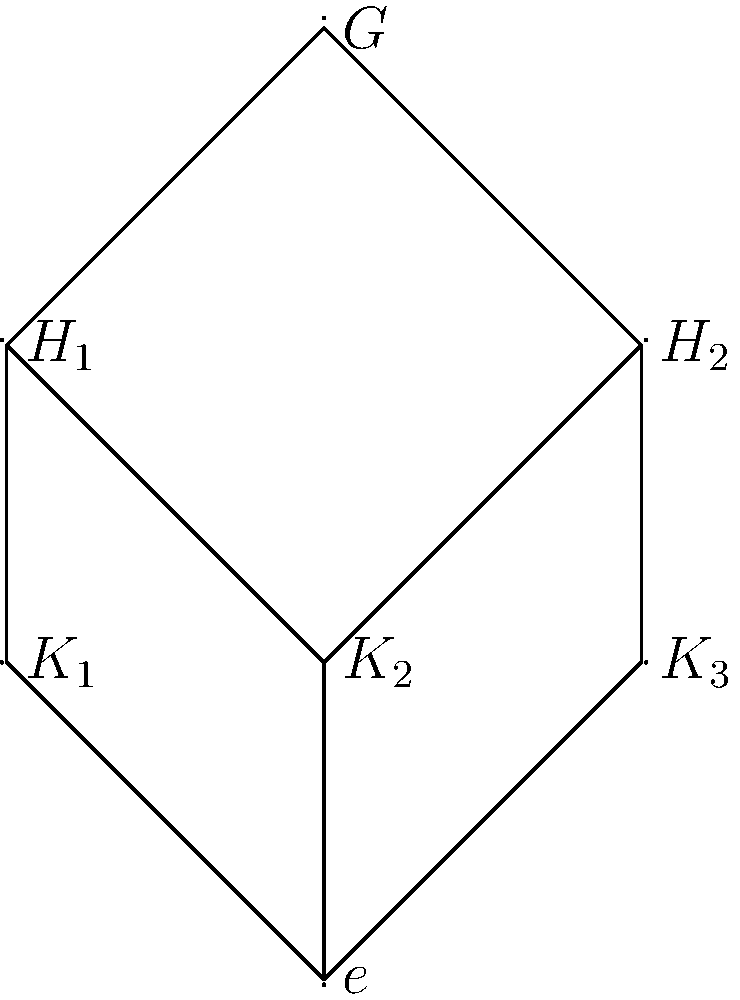Given the subgroup lattice of a group $G$ shown above, which of the following statements is true about the relationship between $H_1$ and $H_2$? Assume you're designing a machine learning algorithm to analyze group structures for efficient transcription of mathematical notations.

a) $H_1 \subset H_2$
b) $H_2 \subset H_1$
c) $H_1 = H_2$
d) $H_1$ and $H_2$ are not directly comparable To answer this question, we need to analyze the subgroup lattice diagram and understand the relationships between subgroups. Let's approach this step-by-step:

1) In a subgroup lattice, if there's a path going upwards from one subgroup to another, it means the lower subgroup is a subset of the higher one.

2) Looking at $H_1$ and $H_2$, we can see that:
   - There's no direct path from $H_1$ to $H_2$ or vice versa.
   - Both $H_1$ and $H_2$ are directly connected to $G$ at the top.
   - $H_1$ and $H_2$ share a common subgroup $K_2$, but also have distinct subgroups ($K_1$ for $H_1$ and $K_3$ for $H_2$).

3) This structure indicates that:
   - $H_1$ is not a subset of $H_2$ (ruling out option a).
   - $H_2$ is not a subset of $H_1$ (ruling out option b).
   - $H_1$ and $H_2$ are not equal, as they have different subgroups (ruling out option c).

4) The correct conclusion is that $H_1$ and $H_2$ are not directly comparable in terms of set inclusion. They are both maximal proper subgroups of $G$, but neither contains the other.

5) In the context of designing machine learning algorithms for mathematical notation transcription, recognizing such relationships quickly can be crucial for efficient processing and representation of group structures.

Therefore, the correct answer is option d: $H_1$ and $H_2$ are not directly comparable.
Answer: d) $H_1$ and $H_2$ are not directly comparable 